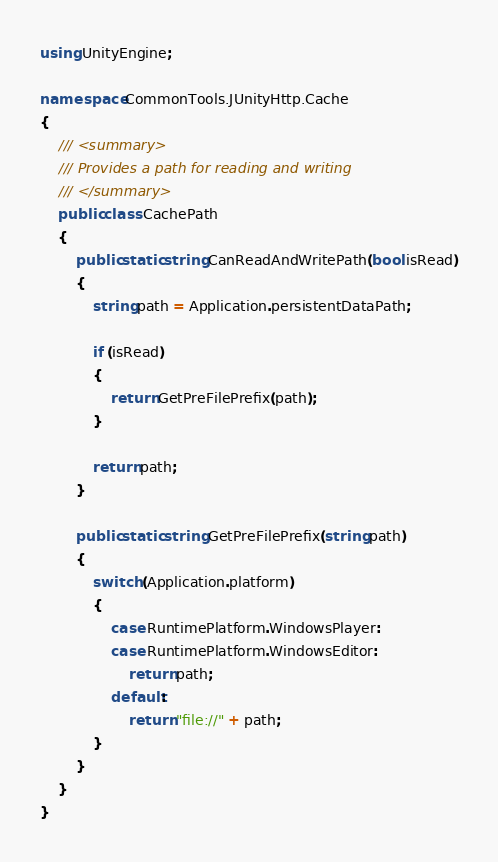Convert code to text. <code><loc_0><loc_0><loc_500><loc_500><_C#_>using UnityEngine;

namespace CommonTools.JUnityHttp.Cache
{
    /// <summary>
    /// Provides a path for reading and writing
    /// </summary>
    public class CachePath
    {
        public static string CanReadAndWritePath(bool isRead)
        {
            string path = Application.persistentDataPath;

            if (isRead)
            {
                return GetPreFilePrefix(path);
            }

            return path;
        }

        public static string GetPreFilePrefix(string path)
        {
            switch (Application.platform)
            {
                case RuntimePlatform.WindowsPlayer:
                case RuntimePlatform.WindowsEditor:
                    return path;
                default:
                    return "file://" + path;
            }
        }
    }
}</code> 